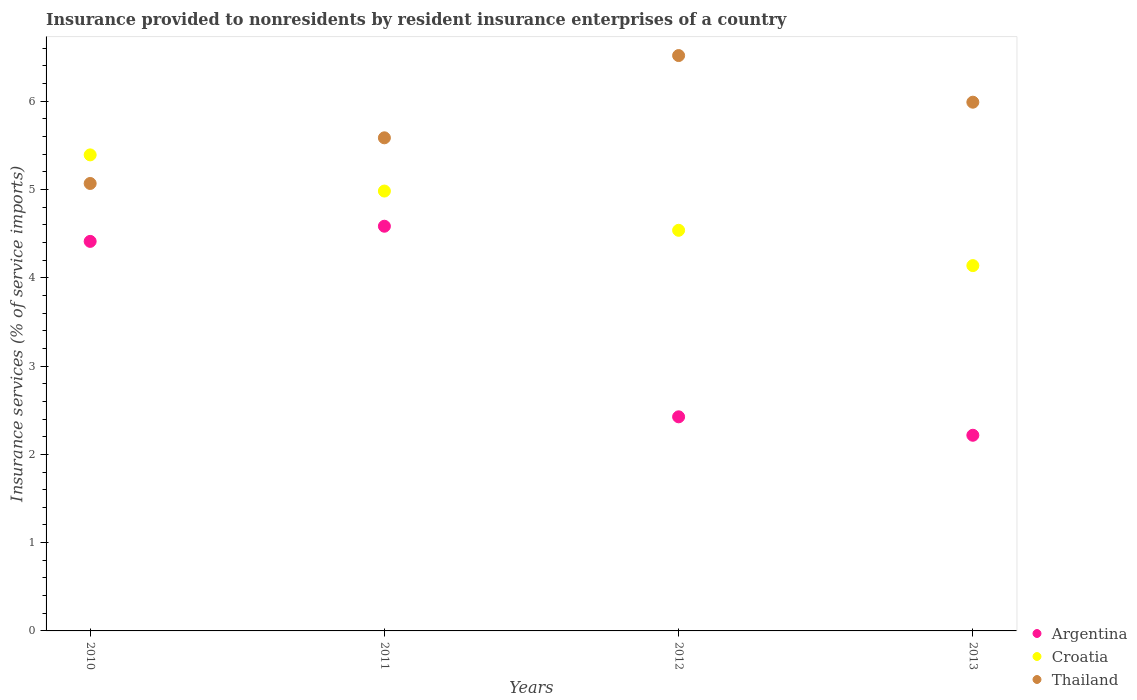Is the number of dotlines equal to the number of legend labels?
Your response must be concise. Yes. What is the insurance provided to nonresidents in Argentina in 2012?
Make the answer very short. 2.43. Across all years, what is the maximum insurance provided to nonresidents in Thailand?
Provide a short and direct response. 6.52. Across all years, what is the minimum insurance provided to nonresidents in Thailand?
Offer a very short reply. 5.07. In which year was the insurance provided to nonresidents in Croatia maximum?
Make the answer very short. 2010. What is the total insurance provided to nonresidents in Croatia in the graph?
Ensure brevity in your answer.  19.05. What is the difference between the insurance provided to nonresidents in Argentina in 2010 and that in 2011?
Ensure brevity in your answer.  -0.17. What is the difference between the insurance provided to nonresidents in Croatia in 2011 and the insurance provided to nonresidents in Thailand in 2013?
Provide a short and direct response. -1.01. What is the average insurance provided to nonresidents in Croatia per year?
Offer a terse response. 4.76. In the year 2010, what is the difference between the insurance provided to nonresidents in Croatia and insurance provided to nonresidents in Thailand?
Your response must be concise. 0.32. In how many years, is the insurance provided to nonresidents in Thailand greater than 6 %?
Provide a short and direct response. 1. What is the ratio of the insurance provided to nonresidents in Argentina in 2011 to that in 2012?
Offer a very short reply. 1.89. Is the insurance provided to nonresidents in Croatia in 2011 less than that in 2012?
Provide a short and direct response. No. Is the difference between the insurance provided to nonresidents in Croatia in 2010 and 2011 greater than the difference between the insurance provided to nonresidents in Thailand in 2010 and 2011?
Keep it short and to the point. Yes. What is the difference between the highest and the second highest insurance provided to nonresidents in Argentina?
Your response must be concise. 0.17. What is the difference between the highest and the lowest insurance provided to nonresidents in Argentina?
Provide a succinct answer. 2.37. In how many years, is the insurance provided to nonresidents in Argentina greater than the average insurance provided to nonresidents in Argentina taken over all years?
Your response must be concise. 2. Is it the case that in every year, the sum of the insurance provided to nonresidents in Argentina and insurance provided to nonresidents in Croatia  is greater than the insurance provided to nonresidents in Thailand?
Ensure brevity in your answer.  Yes. Is the insurance provided to nonresidents in Thailand strictly greater than the insurance provided to nonresidents in Argentina over the years?
Your answer should be very brief. Yes. Is the insurance provided to nonresidents in Thailand strictly less than the insurance provided to nonresidents in Croatia over the years?
Provide a short and direct response. No. How many dotlines are there?
Offer a terse response. 3. Does the graph contain any zero values?
Keep it short and to the point. No. Does the graph contain grids?
Your answer should be compact. No. Where does the legend appear in the graph?
Provide a succinct answer. Bottom right. How many legend labels are there?
Keep it short and to the point. 3. What is the title of the graph?
Offer a very short reply. Insurance provided to nonresidents by resident insurance enterprises of a country. What is the label or title of the Y-axis?
Keep it short and to the point. Insurance services (% of service imports). What is the Insurance services (% of service imports) in Argentina in 2010?
Ensure brevity in your answer.  4.41. What is the Insurance services (% of service imports) in Croatia in 2010?
Ensure brevity in your answer.  5.39. What is the Insurance services (% of service imports) of Thailand in 2010?
Ensure brevity in your answer.  5.07. What is the Insurance services (% of service imports) in Argentina in 2011?
Make the answer very short. 4.58. What is the Insurance services (% of service imports) in Croatia in 2011?
Provide a succinct answer. 4.98. What is the Insurance services (% of service imports) in Thailand in 2011?
Your response must be concise. 5.59. What is the Insurance services (% of service imports) of Argentina in 2012?
Provide a short and direct response. 2.43. What is the Insurance services (% of service imports) of Croatia in 2012?
Give a very brief answer. 4.54. What is the Insurance services (% of service imports) in Thailand in 2012?
Make the answer very short. 6.52. What is the Insurance services (% of service imports) of Argentina in 2013?
Your answer should be very brief. 2.22. What is the Insurance services (% of service imports) of Croatia in 2013?
Provide a short and direct response. 4.14. What is the Insurance services (% of service imports) of Thailand in 2013?
Give a very brief answer. 5.99. Across all years, what is the maximum Insurance services (% of service imports) in Argentina?
Give a very brief answer. 4.58. Across all years, what is the maximum Insurance services (% of service imports) in Croatia?
Make the answer very short. 5.39. Across all years, what is the maximum Insurance services (% of service imports) of Thailand?
Offer a terse response. 6.52. Across all years, what is the minimum Insurance services (% of service imports) in Argentina?
Offer a terse response. 2.22. Across all years, what is the minimum Insurance services (% of service imports) of Croatia?
Offer a terse response. 4.14. Across all years, what is the minimum Insurance services (% of service imports) of Thailand?
Keep it short and to the point. 5.07. What is the total Insurance services (% of service imports) in Argentina in the graph?
Provide a succinct answer. 13.64. What is the total Insurance services (% of service imports) in Croatia in the graph?
Ensure brevity in your answer.  19.05. What is the total Insurance services (% of service imports) of Thailand in the graph?
Make the answer very short. 23.16. What is the difference between the Insurance services (% of service imports) in Argentina in 2010 and that in 2011?
Make the answer very short. -0.17. What is the difference between the Insurance services (% of service imports) of Croatia in 2010 and that in 2011?
Offer a terse response. 0.41. What is the difference between the Insurance services (% of service imports) in Thailand in 2010 and that in 2011?
Ensure brevity in your answer.  -0.52. What is the difference between the Insurance services (% of service imports) of Argentina in 2010 and that in 2012?
Make the answer very short. 1.99. What is the difference between the Insurance services (% of service imports) of Croatia in 2010 and that in 2012?
Your answer should be very brief. 0.85. What is the difference between the Insurance services (% of service imports) in Thailand in 2010 and that in 2012?
Keep it short and to the point. -1.45. What is the difference between the Insurance services (% of service imports) of Argentina in 2010 and that in 2013?
Give a very brief answer. 2.2. What is the difference between the Insurance services (% of service imports) in Croatia in 2010 and that in 2013?
Offer a very short reply. 1.25. What is the difference between the Insurance services (% of service imports) in Thailand in 2010 and that in 2013?
Your answer should be very brief. -0.92. What is the difference between the Insurance services (% of service imports) of Argentina in 2011 and that in 2012?
Offer a very short reply. 2.16. What is the difference between the Insurance services (% of service imports) in Croatia in 2011 and that in 2012?
Your answer should be compact. 0.44. What is the difference between the Insurance services (% of service imports) in Thailand in 2011 and that in 2012?
Offer a very short reply. -0.93. What is the difference between the Insurance services (% of service imports) of Argentina in 2011 and that in 2013?
Offer a very short reply. 2.37. What is the difference between the Insurance services (% of service imports) in Croatia in 2011 and that in 2013?
Ensure brevity in your answer.  0.84. What is the difference between the Insurance services (% of service imports) of Thailand in 2011 and that in 2013?
Give a very brief answer. -0.4. What is the difference between the Insurance services (% of service imports) in Argentina in 2012 and that in 2013?
Ensure brevity in your answer.  0.21. What is the difference between the Insurance services (% of service imports) of Thailand in 2012 and that in 2013?
Keep it short and to the point. 0.53. What is the difference between the Insurance services (% of service imports) of Argentina in 2010 and the Insurance services (% of service imports) of Croatia in 2011?
Provide a succinct answer. -0.57. What is the difference between the Insurance services (% of service imports) in Argentina in 2010 and the Insurance services (% of service imports) in Thailand in 2011?
Make the answer very short. -1.17. What is the difference between the Insurance services (% of service imports) in Croatia in 2010 and the Insurance services (% of service imports) in Thailand in 2011?
Offer a terse response. -0.19. What is the difference between the Insurance services (% of service imports) of Argentina in 2010 and the Insurance services (% of service imports) of Croatia in 2012?
Your response must be concise. -0.13. What is the difference between the Insurance services (% of service imports) of Argentina in 2010 and the Insurance services (% of service imports) of Thailand in 2012?
Offer a terse response. -2.1. What is the difference between the Insurance services (% of service imports) of Croatia in 2010 and the Insurance services (% of service imports) of Thailand in 2012?
Provide a succinct answer. -1.13. What is the difference between the Insurance services (% of service imports) of Argentina in 2010 and the Insurance services (% of service imports) of Croatia in 2013?
Your response must be concise. 0.27. What is the difference between the Insurance services (% of service imports) of Argentina in 2010 and the Insurance services (% of service imports) of Thailand in 2013?
Your answer should be very brief. -1.58. What is the difference between the Insurance services (% of service imports) of Croatia in 2010 and the Insurance services (% of service imports) of Thailand in 2013?
Provide a succinct answer. -0.6. What is the difference between the Insurance services (% of service imports) in Argentina in 2011 and the Insurance services (% of service imports) in Croatia in 2012?
Provide a short and direct response. 0.05. What is the difference between the Insurance services (% of service imports) in Argentina in 2011 and the Insurance services (% of service imports) in Thailand in 2012?
Your answer should be compact. -1.93. What is the difference between the Insurance services (% of service imports) of Croatia in 2011 and the Insurance services (% of service imports) of Thailand in 2012?
Your answer should be very brief. -1.53. What is the difference between the Insurance services (% of service imports) of Argentina in 2011 and the Insurance services (% of service imports) of Croatia in 2013?
Your answer should be very brief. 0.45. What is the difference between the Insurance services (% of service imports) in Argentina in 2011 and the Insurance services (% of service imports) in Thailand in 2013?
Your answer should be compact. -1.4. What is the difference between the Insurance services (% of service imports) in Croatia in 2011 and the Insurance services (% of service imports) in Thailand in 2013?
Ensure brevity in your answer.  -1.01. What is the difference between the Insurance services (% of service imports) of Argentina in 2012 and the Insurance services (% of service imports) of Croatia in 2013?
Give a very brief answer. -1.71. What is the difference between the Insurance services (% of service imports) of Argentina in 2012 and the Insurance services (% of service imports) of Thailand in 2013?
Offer a terse response. -3.56. What is the difference between the Insurance services (% of service imports) of Croatia in 2012 and the Insurance services (% of service imports) of Thailand in 2013?
Provide a succinct answer. -1.45. What is the average Insurance services (% of service imports) in Argentina per year?
Keep it short and to the point. 3.41. What is the average Insurance services (% of service imports) of Croatia per year?
Keep it short and to the point. 4.76. What is the average Insurance services (% of service imports) of Thailand per year?
Provide a succinct answer. 5.79. In the year 2010, what is the difference between the Insurance services (% of service imports) of Argentina and Insurance services (% of service imports) of Croatia?
Make the answer very short. -0.98. In the year 2010, what is the difference between the Insurance services (% of service imports) of Argentina and Insurance services (% of service imports) of Thailand?
Your response must be concise. -0.66. In the year 2010, what is the difference between the Insurance services (% of service imports) of Croatia and Insurance services (% of service imports) of Thailand?
Offer a very short reply. 0.32. In the year 2011, what is the difference between the Insurance services (% of service imports) of Argentina and Insurance services (% of service imports) of Croatia?
Give a very brief answer. -0.4. In the year 2011, what is the difference between the Insurance services (% of service imports) of Argentina and Insurance services (% of service imports) of Thailand?
Offer a terse response. -1. In the year 2011, what is the difference between the Insurance services (% of service imports) of Croatia and Insurance services (% of service imports) of Thailand?
Offer a terse response. -0.6. In the year 2012, what is the difference between the Insurance services (% of service imports) of Argentina and Insurance services (% of service imports) of Croatia?
Give a very brief answer. -2.11. In the year 2012, what is the difference between the Insurance services (% of service imports) of Argentina and Insurance services (% of service imports) of Thailand?
Ensure brevity in your answer.  -4.09. In the year 2012, what is the difference between the Insurance services (% of service imports) in Croatia and Insurance services (% of service imports) in Thailand?
Provide a short and direct response. -1.98. In the year 2013, what is the difference between the Insurance services (% of service imports) of Argentina and Insurance services (% of service imports) of Croatia?
Offer a terse response. -1.92. In the year 2013, what is the difference between the Insurance services (% of service imports) in Argentina and Insurance services (% of service imports) in Thailand?
Provide a short and direct response. -3.77. In the year 2013, what is the difference between the Insurance services (% of service imports) in Croatia and Insurance services (% of service imports) in Thailand?
Keep it short and to the point. -1.85. What is the ratio of the Insurance services (% of service imports) in Argentina in 2010 to that in 2011?
Keep it short and to the point. 0.96. What is the ratio of the Insurance services (% of service imports) in Croatia in 2010 to that in 2011?
Give a very brief answer. 1.08. What is the ratio of the Insurance services (% of service imports) in Thailand in 2010 to that in 2011?
Your answer should be compact. 0.91. What is the ratio of the Insurance services (% of service imports) of Argentina in 2010 to that in 2012?
Make the answer very short. 1.82. What is the ratio of the Insurance services (% of service imports) of Croatia in 2010 to that in 2012?
Make the answer very short. 1.19. What is the ratio of the Insurance services (% of service imports) of Thailand in 2010 to that in 2012?
Give a very brief answer. 0.78. What is the ratio of the Insurance services (% of service imports) of Argentina in 2010 to that in 2013?
Give a very brief answer. 1.99. What is the ratio of the Insurance services (% of service imports) of Croatia in 2010 to that in 2013?
Your answer should be very brief. 1.3. What is the ratio of the Insurance services (% of service imports) of Thailand in 2010 to that in 2013?
Your answer should be compact. 0.85. What is the ratio of the Insurance services (% of service imports) of Argentina in 2011 to that in 2012?
Offer a very short reply. 1.89. What is the ratio of the Insurance services (% of service imports) of Croatia in 2011 to that in 2012?
Your answer should be very brief. 1.1. What is the ratio of the Insurance services (% of service imports) in Thailand in 2011 to that in 2012?
Your answer should be compact. 0.86. What is the ratio of the Insurance services (% of service imports) of Argentina in 2011 to that in 2013?
Make the answer very short. 2.07. What is the ratio of the Insurance services (% of service imports) of Croatia in 2011 to that in 2013?
Offer a very short reply. 1.2. What is the ratio of the Insurance services (% of service imports) of Thailand in 2011 to that in 2013?
Offer a very short reply. 0.93. What is the ratio of the Insurance services (% of service imports) in Argentina in 2012 to that in 2013?
Keep it short and to the point. 1.09. What is the ratio of the Insurance services (% of service imports) of Croatia in 2012 to that in 2013?
Your answer should be compact. 1.1. What is the ratio of the Insurance services (% of service imports) in Thailand in 2012 to that in 2013?
Ensure brevity in your answer.  1.09. What is the difference between the highest and the second highest Insurance services (% of service imports) in Argentina?
Give a very brief answer. 0.17. What is the difference between the highest and the second highest Insurance services (% of service imports) in Croatia?
Offer a very short reply. 0.41. What is the difference between the highest and the second highest Insurance services (% of service imports) of Thailand?
Offer a very short reply. 0.53. What is the difference between the highest and the lowest Insurance services (% of service imports) in Argentina?
Your answer should be very brief. 2.37. What is the difference between the highest and the lowest Insurance services (% of service imports) in Croatia?
Keep it short and to the point. 1.25. What is the difference between the highest and the lowest Insurance services (% of service imports) of Thailand?
Your response must be concise. 1.45. 